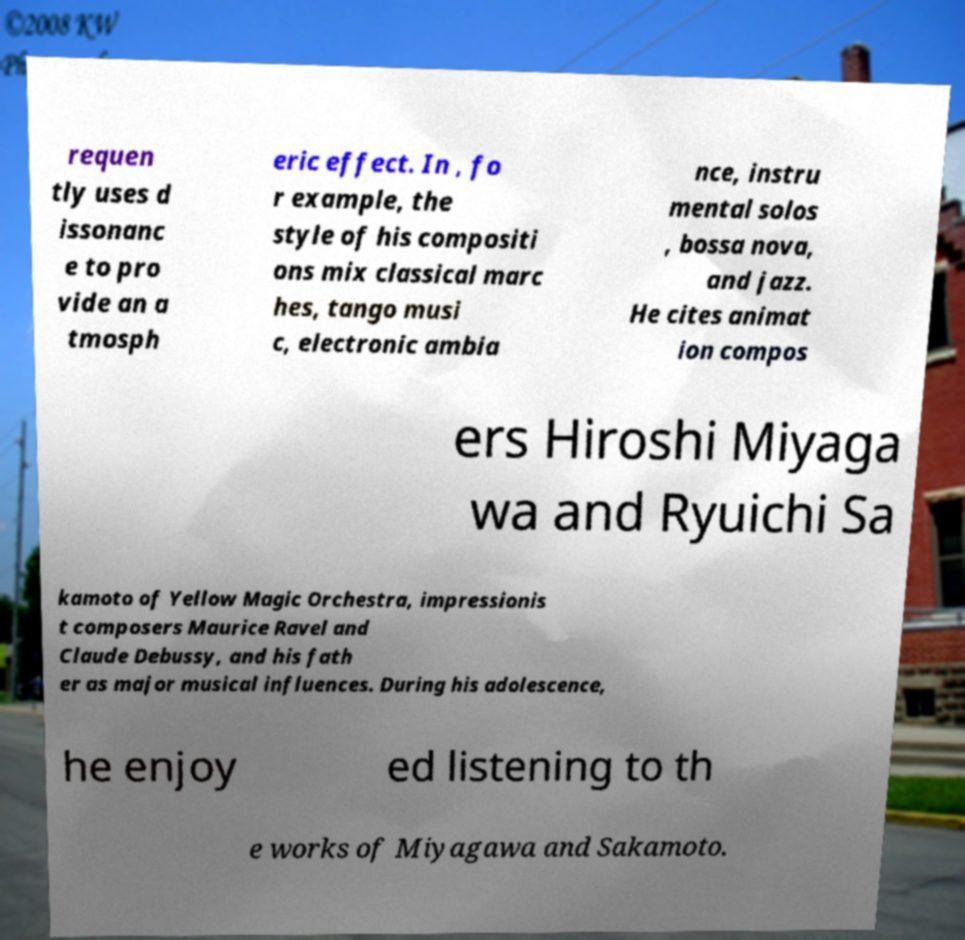For documentation purposes, I need the text within this image transcribed. Could you provide that? requen tly uses d issonanc e to pro vide an a tmosph eric effect. In , fo r example, the style of his compositi ons mix classical marc hes, tango musi c, electronic ambia nce, instru mental solos , bossa nova, and jazz. He cites animat ion compos ers Hiroshi Miyaga wa and Ryuichi Sa kamoto of Yellow Magic Orchestra, impressionis t composers Maurice Ravel and Claude Debussy, and his fath er as major musical influences. During his adolescence, he enjoy ed listening to th e works of Miyagawa and Sakamoto. 